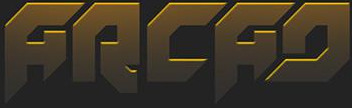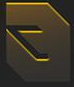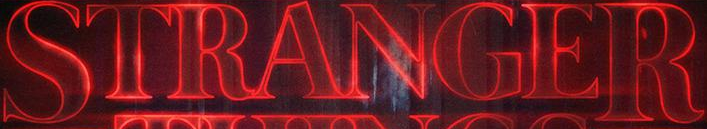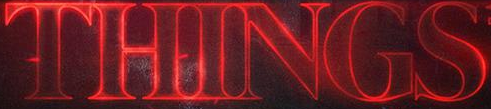Read the text content from these images in order, separated by a semicolon. ARCAD; #; STRANGER; THINGS 